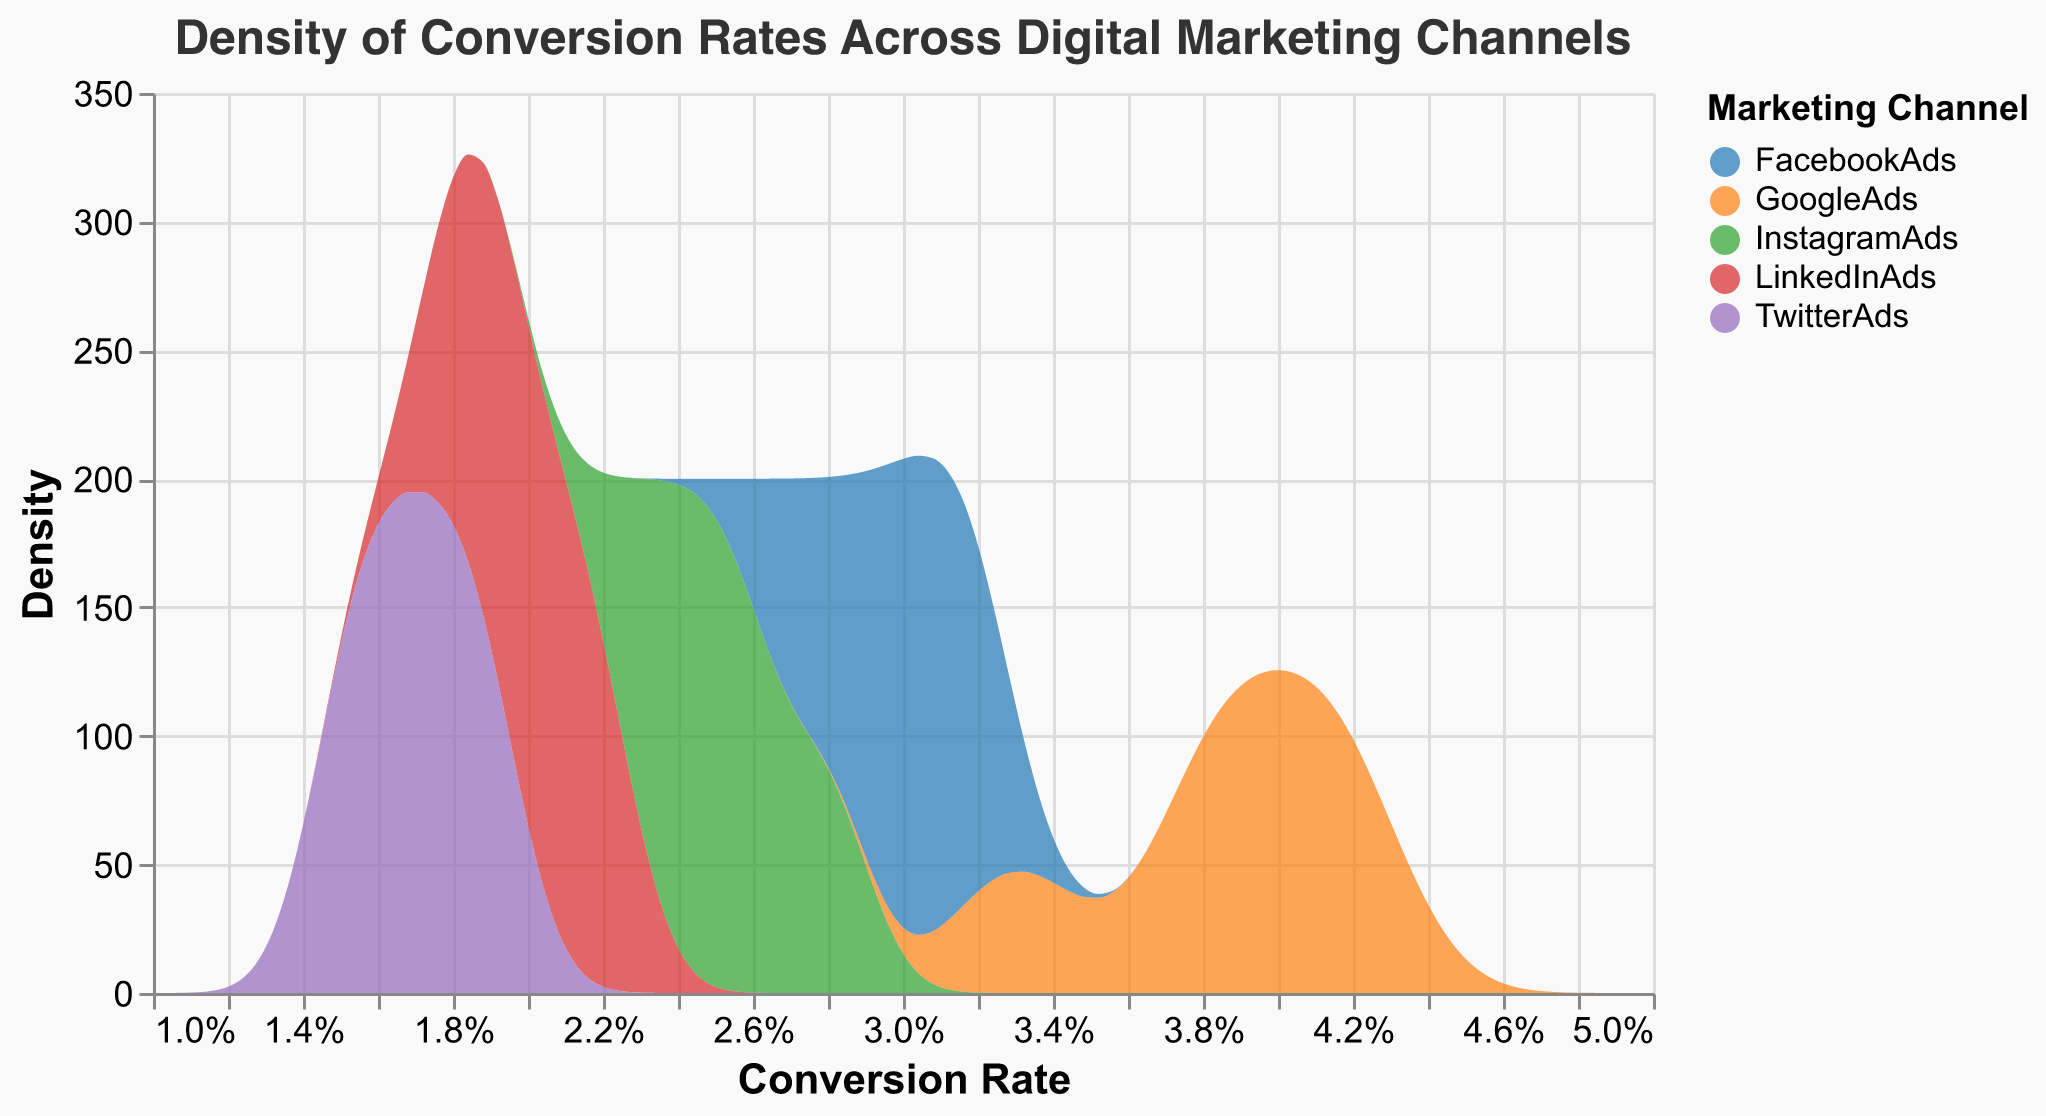How many different marketing channels are depicted in the density plot? The density plot uses color to differentiate between marketing channels, and there are five distinct colors used in the legend, signifying five marketing channels.
Answer: Five What is the general shape of the density plot for GoogleAds? The density plot for GoogleAds shows a smooth curve that peaks within the conversion rate range of approximately 3.8% to 4.2%. This indicates the distribution of conversion rates for GoogleAds.
Answer: Smooth curve peaking from 3.8% to 4.2% Which marketing channel has the lowest conversion rates according to the density plot? By examining the density plot, we can see that TwitterAds has the lowest range of conversion rates, indicated by its curve peaking around 1.5% to 1.8%.
Answer: TwitterAds How does the peak density value of FacebookAds compare with that of InstagramAds? The peak density value for both FacebookAds and InstagramAds can be compared by looking at their respective curves. FacebookAds has a higher peak density value around 3.0%, while InstagramAds has a peak around 2.5%.
Answer: FacebookAds has a higher peak Which marketing channel's conversion rate density plot has the widest range? The width of the range for a density plot can be assessed by looking at the spread of the curve. GoogleAds shows the widest range, spreading from about 3.3% to 4.2%.
Answer: GoogleAds Are the density plots for LinkedInAds and TwitterAds overlap? To determine any overlap, we look at where the curves intersect. The curves for LinkedInAds and TwitterAds, which range from 1.8% to 2.2% and 1.5% to 1.9% respectively, indicate some overlap in the conversion rate range between 1.8% to 1.9%.
Answer: Yes, between 1.8% to 1.9% Which marketing channel shows the highest variability in conversion rates? Variability in this context can be gauged by the width of the density plot's curve range. GoogleAds has the highest variability as its curve spans a wider range of conversion rates, from about 3.3% to 4.2%.
Answer: GoogleAds What is the conversion rate range where all channels have non-zero density values? We observe the range where all density plots are above zero. For all channels, this range would be the overlap from approximately 2.0% to 2.2%.
Answer: 2.0% to 2.2% Which marketing channel has the steepest density curve, indicating the least variability? A steep density curve indicates less variability in conversion rates. TwitterAds, with a steep curve peaking sharply at around 1.7%, shows the least variability.
Answer: TwitterAds 